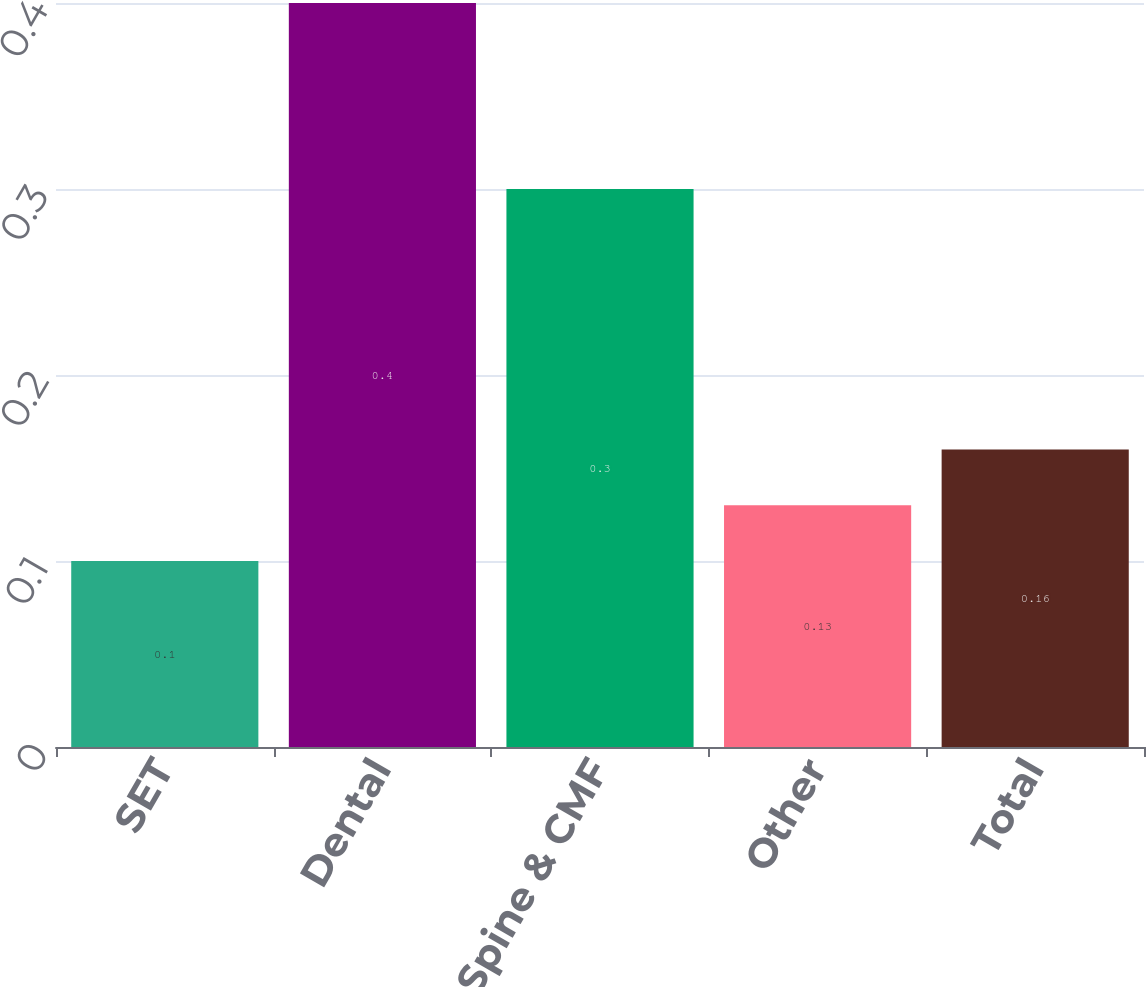<chart> <loc_0><loc_0><loc_500><loc_500><bar_chart><fcel>SET<fcel>Dental<fcel>Spine & CMF<fcel>Other<fcel>Total<nl><fcel>0.1<fcel>0.4<fcel>0.3<fcel>0.13<fcel>0.16<nl></chart> 